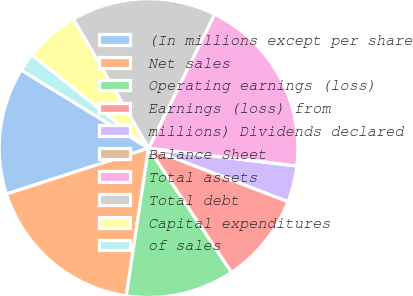<chart> <loc_0><loc_0><loc_500><loc_500><pie_chart><fcel>(In millions except per share<fcel>Net sales<fcel>Operating earnings (loss)<fcel>Earnings (loss) from<fcel>millions) Dividends declared<fcel>Balance Sheet<fcel>Total assets<fcel>Total debt<fcel>Capital expenditures<fcel>of sales<nl><fcel>13.72%<fcel>17.64%<fcel>11.76%<fcel>9.8%<fcel>3.92%<fcel>0.0%<fcel>19.6%<fcel>15.68%<fcel>5.88%<fcel>1.96%<nl></chart> 